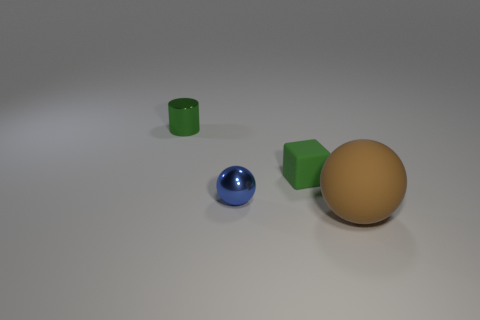Add 1 tiny blue spheres. How many objects exist? 5 Add 2 tiny blue rubber spheres. How many tiny blue rubber spheres exist? 2 Subtract 0 purple blocks. How many objects are left? 4 Subtract all blocks. How many objects are left? 3 Subtract all small gray rubber objects. Subtract all tiny green objects. How many objects are left? 2 Add 1 tiny metallic balls. How many tiny metallic balls are left? 2 